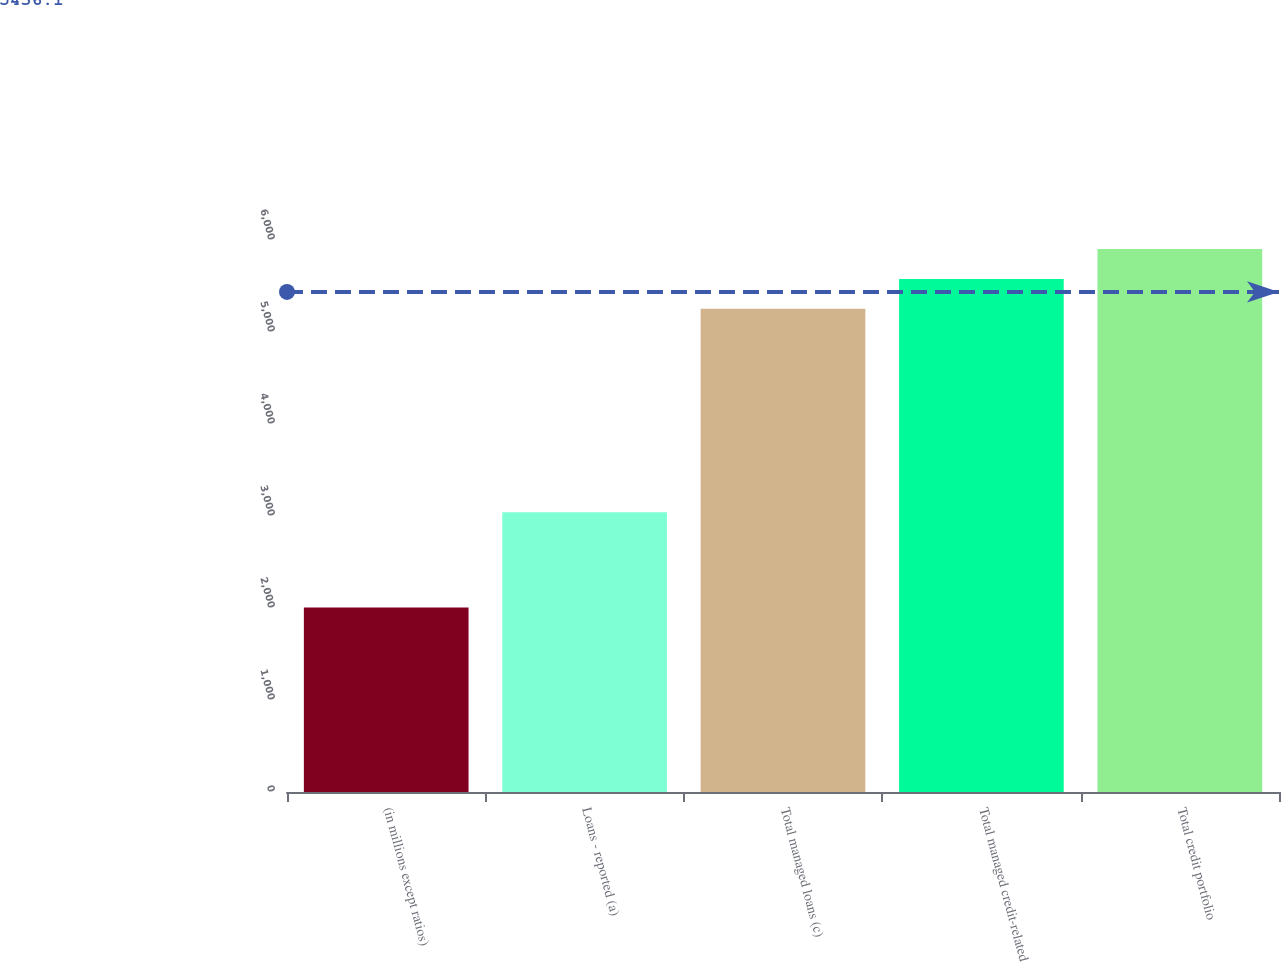<chart> <loc_0><loc_0><loc_500><loc_500><bar_chart><fcel>(in millions except ratios)<fcel>Loans - reported (a)<fcel>Total managed loans (c)<fcel>Total managed credit-related<fcel>Total credit portfolio<nl><fcel>2006<fcel>3042<fcel>5252<fcel>5576.6<fcel>5901.2<nl></chart> 